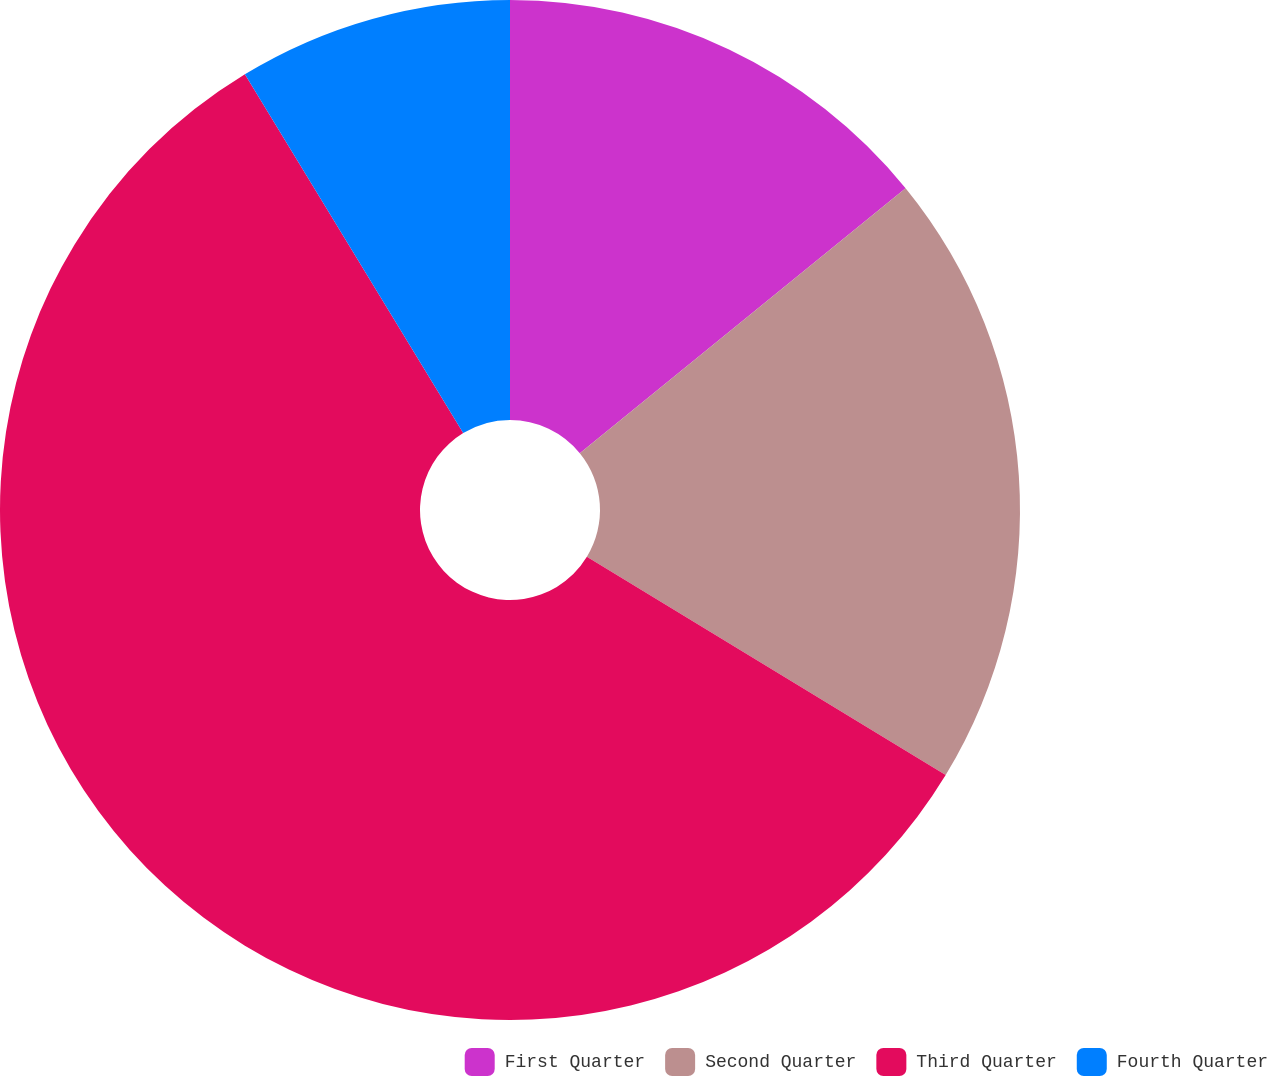Convert chart. <chart><loc_0><loc_0><loc_500><loc_500><pie_chart><fcel>First Quarter<fcel>Second Quarter<fcel>Third Quarter<fcel>Fourth Quarter<nl><fcel>14.13%<fcel>19.57%<fcel>57.6%<fcel>8.7%<nl></chart> 